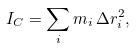Convert formula to latex. <formula><loc_0><loc_0><loc_500><loc_500>I _ { C } = \sum _ { i } m _ { i } \, \Delta r _ { i } ^ { 2 } ,</formula> 